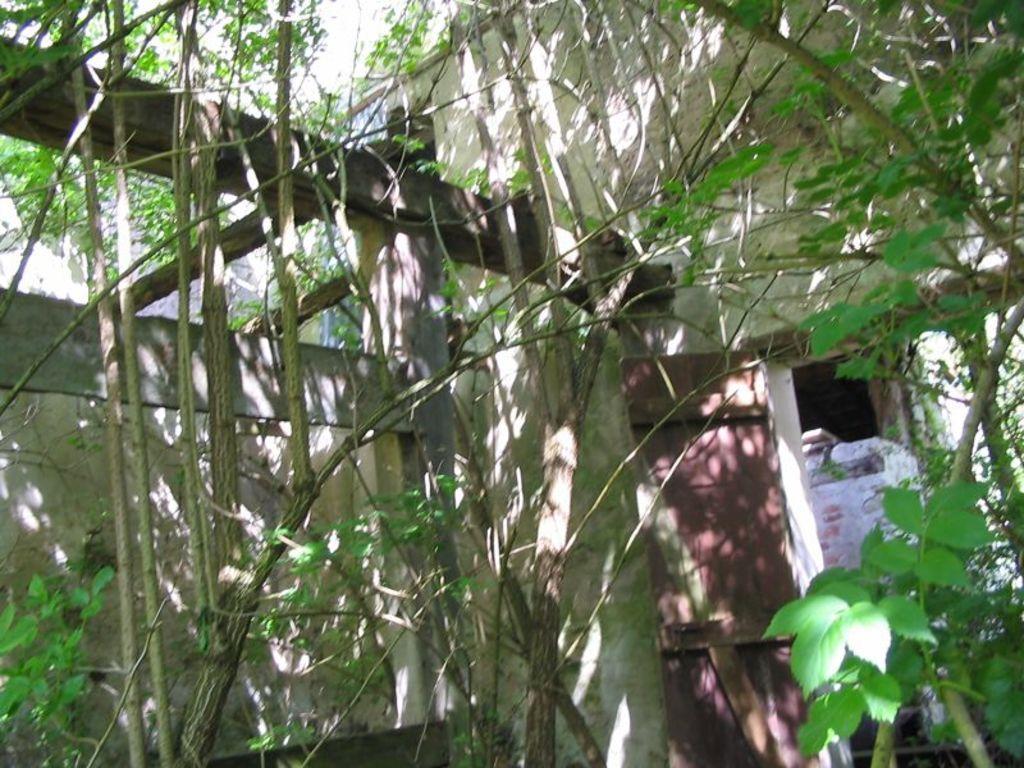In one or two sentences, can you explain what this image depicts? This image consist of plants and there is a door and there is a wall. 